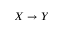<formula> <loc_0><loc_0><loc_500><loc_500>X \to Y</formula> 